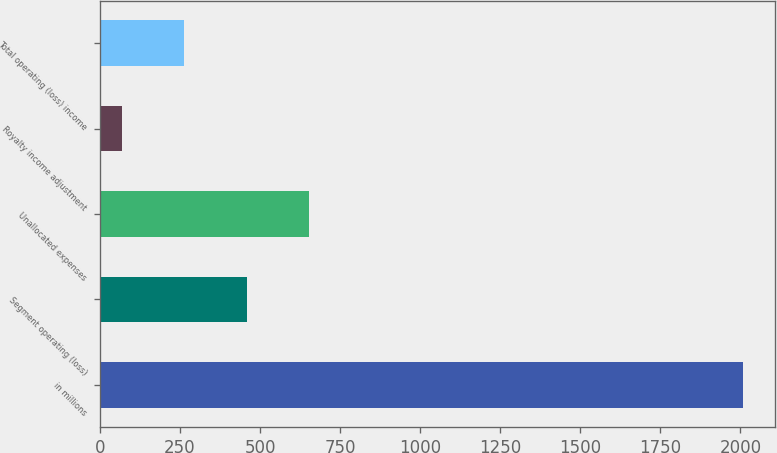<chart> <loc_0><loc_0><loc_500><loc_500><bar_chart><fcel>in millions<fcel>Segment operating (loss)<fcel>Unallocated expenses<fcel>Royalty income adjustment<fcel>Total operating (loss) income<nl><fcel>2008<fcel>457.6<fcel>651.4<fcel>70<fcel>263.8<nl></chart> 